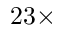<formula> <loc_0><loc_0><loc_500><loc_500>2 3 \times</formula> 